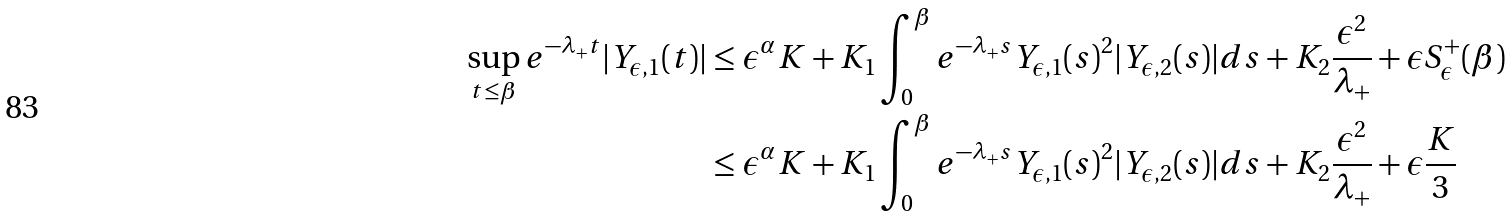Convert formula to latex. <formula><loc_0><loc_0><loc_500><loc_500>\sup _ { t \leq \beta } e ^ { - \lambda _ { + } t } | Y _ { \epsilon , 1 } ( t ) | & \leq \epsilon ^ { \alpha } K + K _ { 1 } \int _ { 0 } ^ { \beta } e ^ { - \lambda _ { + } s } Y _ { \epsilon , 1 } ( s ) ^ { 2 } | Y _ { \epsilon , 2 } ( s ) | d s + K _ { 2 } \frac { \epsilon ^ { 2 } } { \lambda _ { + } } + \epsilon S _ { \epsilon } ^ { + } ( \beta ) \\ & \leq \epsilon ^ { \alpha } K + K _ { 1 } \int _ { 0 } ^ { \beta } e ^ { - \lambda _ { + } s } Y _ { \epsilon , 1 } ( s ) ^ { 2 } | Y _ { \epsilon , 2 } ( s ) | d s + K _ { 2 } \frac { \epsilon ^ { 2 } } { \lambda _ { + } } + \epsilon \frac { K } { 3 }</formula> 